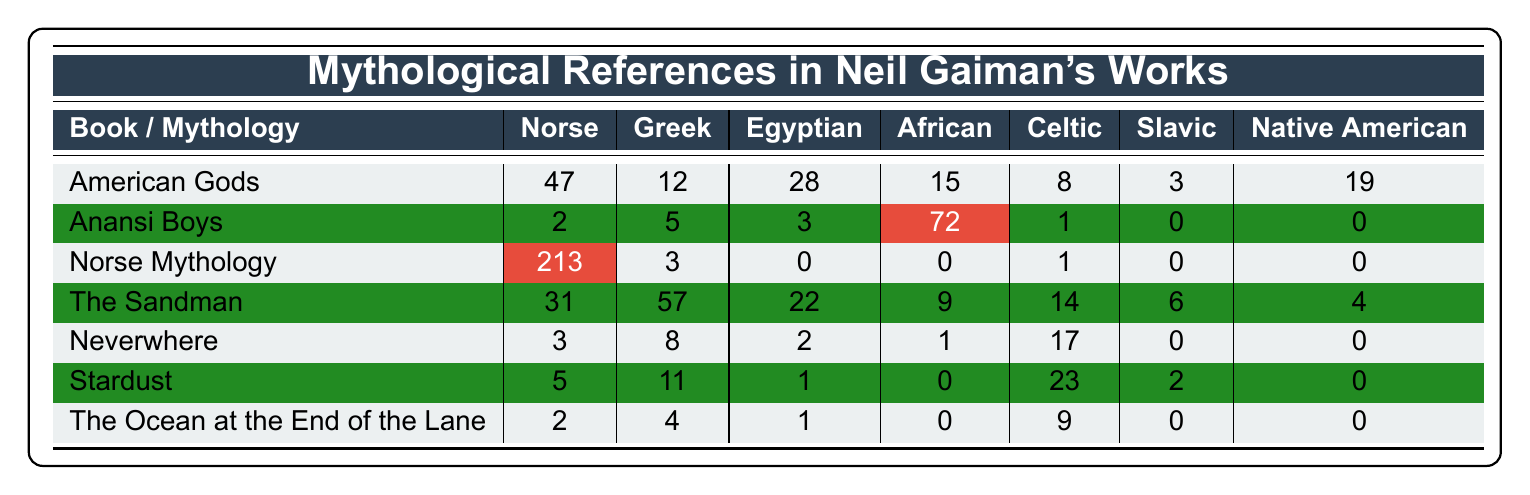What is the highest frequency of mythological references in a single book? "Norse Mythology" has the highest frequency with 213 references, which is visually identifiable in the table.
Answer: 213 How many African mythological references are there in "Anansi Boys"? "Anansi Boys" shows 72 African mythological references, as seen directly in the table.
Answer: 72 Which book contains the least number of Slavic references? "Anansi Boys" and "Norse Mythology" both have 0 Slavic references, making them the lowest in that category, as indicated in the table.
Answer: 0 What is the total number of Egyptian references across all books? Adding the Egyptian references: 28 (American Gods) + 0 (Anansi Boys) + 0 (Norse Mythology) + 22 (The Sandman) + 2 (Neverwhere) + 1 (Stardust) + 1 (The Ocean at the End of the Lane) gives 54.
Answer: 54 Which book has the most diverse mythological references? "The Sandman" features references from six different mythologies (Norse, Greek, Egyptian, African, Celtic, and Slavic), showing a variety compared to others.
Answer: The Sandman How does the number of Norse references in "Norse Mythology" compare to the total Norse references in other books? "Norse Mythology" has 213 Norse references. The total for other books: 47 + 2 + 31 + 3 + 5 + 2 = 90. Comparing yields that "Norse Mythology" has significantly more.
Answer: Much higher Is there a book where all mythologies have non-zero references? Yes, "The Sandman" contains references from all categories except for Slavic and Native American, indicating a broader representation.
Answer: Yes What is the average number of Greek references across all books? The total Greek references are: 12 (American Gods) + 5 (Anansi Boys) + 3 (Norse Mythology) + 57 (The Sandman) + 8 (Neverwhere) + 11 (Stardust) + 4 (The Ocean at the End of the Lane) = 100. There are 7 books, so average = 100/7 ≈ 14.3.
Answer: Approximately 14.3 How many more references to Celtic mythology are in "Stardust" than in "Neverwhere"? "Stardust" has 23 Celtic references while "Neverwhere" has 17; therefore, the difference is 23 - 17 = 6.
Answer: 6 Which mythology has the least overall references across all books? Slavic mythology has the least overall, with only 11 references (3 in American Gods, 0 in Anansi Boys, 0 in Norse Mythology, 6 in The Sandman, 0 in Neverwhere, 2 in Stardust, and 0 in The Ocean at the End of the Lane).
Answer: Slavic What is the combined total of Norse and Native American references in "American Gods"? In "American Gods", there are 47 Norse and 19 Native American references. Adding these gives 47 + 19 = 66.
Answer: 66 